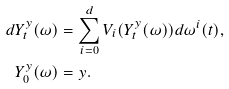Convert formula to latex. <formula><loc_0><loc_0><loc_500><loc_500>d Y _ { t } ^ { y } ( \omega ) & = \sum _ { i = 0 } ^ { d } V _ { i } ( Y _ { t } ^ { y } ( \omega ) ) d \omega ^ { i } ( t ) , \\ Y _ { 0 } ^ { y } ( \omega ) & = y .</formula> 